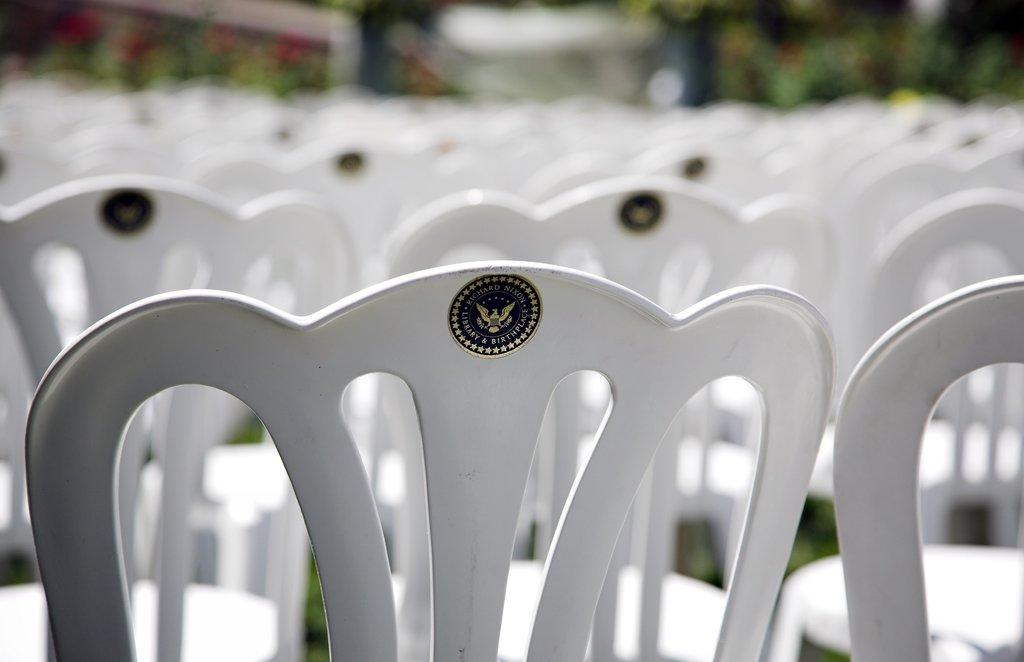What objects are located in the front of the image? There is a group of chairs in the front of the image. What can be seen in the distance in the image? There are trees in the background of the image. How would you describe the appearance of the background in the image? The background of the image is slightly blurred. What type of paper is being used for the vacation in the image? There is no paper or vacation mentioned in the image; it only features a group of chairs and trees in the background. 